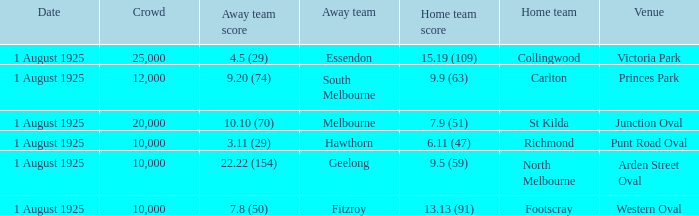At the match where the away team scored 4.5 (29), what was the crowd size? 1.0. 